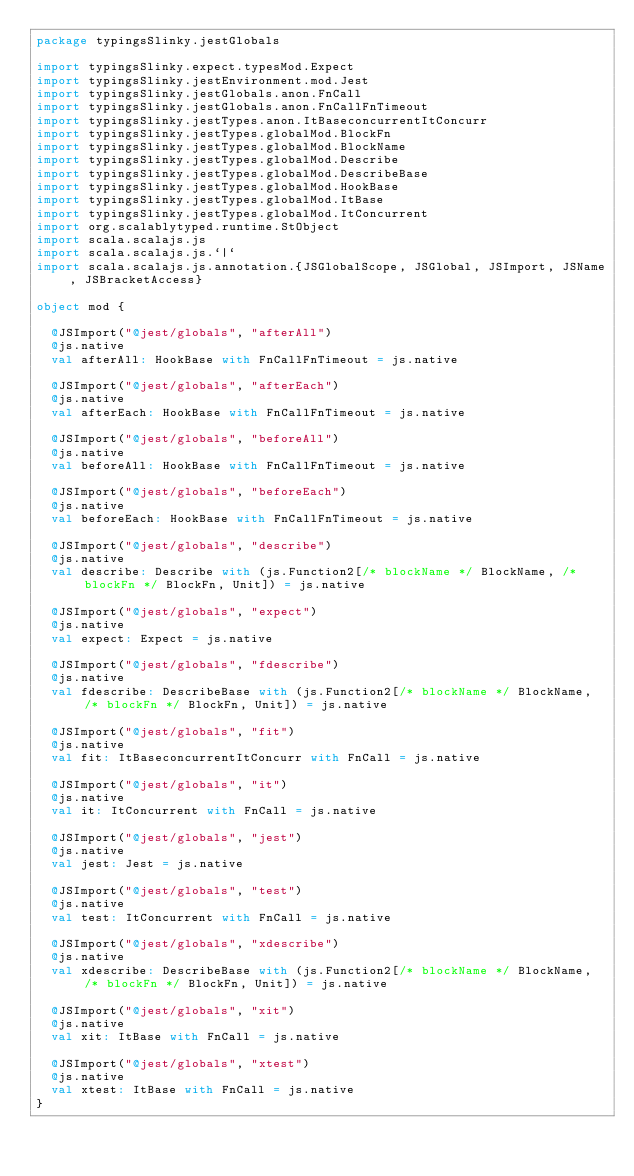Convert code to text. <code><loc_0><loc_0><loc_500><loc_500><_Scala_>package typingsSlinky.jestGlobals

import typingsSlinky.expect.typesMod.Expect
import typingsSlinky.jestEnvironment.mod.Jest
import typingsSlinky.jestGlobals.anon.FnCall
import typingsSlinky.jestGlobals.anon.FnCallFnTimeout
import typingsSlinky.jestTypes.anon.ItBaseconcurrentItConcurr
import typingsSlinky.jestTypes.globalMod.BlockFn
import typingsSlinky.jestTypes.globalMod.BlockName
import typingsSlinky.jestTypes.globalMod.Describe
import typingsSlinky.jestTypes.globalMod.DescribeBase
import typingsSlinky.jestTypes.globalMod.HookBase
import typingsSlinky.jestTypes.globalMod.ItBase
import typingsSlinky.jestTypes.globalMod.ItConcurrent
import org.scalablytyped.runtime.StObject
import scala.scalajs.js
import scala.scalajs.js.`|`
import scala.scalajs.js.annotation.{JSGlobalScope, JSGlobal, JSImport, JSName, JSBracketAccess}

object mod {
  
  @JSImport("@jest/globals", "afterAll")
  @js.native
  val afterAll: HookBase with FnCallFnTimeout = js.native
  
  @JSImport("@jest/globals", "afterEach")
  @js.native
  val afterEach: HookBase with FnCallFnTimeout = js.native
  
  @JSImport("@jest/globals", "beforeAll")
  @js.native
  val beforeAll: HookBase with FnCallFnTimeout = js.native
  
  @JSImport("@jest/globals", "beforeEach")
  @js.native
  val beforeEach: HookBase with FnCallFnTimeout = js.native
  
  @JSImport("@jest/globals", "describe")
  @js.native
  val describe: Describe with (js.Function2[/* blockName */ BlockName, /* blockFn */ BlockFn, Unit]) = js.native
  
  @JSImport("@jest/globals", "expect")
  @js.native
  val expect: Expect = js.native
  
  @JSImport("@jest/globals", "fdescribe")
  @js.native
  val fdescribe: DescribeBase with (js.Function2[/* blockName */ BlockName, /* blockFn */ BlockFn, Unit]) = js.native
  
  @JSImport("@jest/globals", "fit")
  @js.native
  val fit: ItBaseconcurrentItConcurr with FnCall = js.native
  
  @JSImport("@jest/globals", "it")
  @js.native
  val it: ItConcurrent with FnCall = js.native
  
  @JSImport("@jest/globals", "jest")
  @js.native
  val jest: Jest = js.native
  
  @JSImport("@jest/globals", "test")
  @js.native
  val test: ItConcurrent with FnCall = js.native
  
  @JSImport("@jest/globals", "xdescribe")
  @js.native
  val xdescribe: DescribeBase with (js.Function2[/* blockName */ BlockName, /* blockFn */ BlockFn, Unit]) = js.native
  
  @JSImport("@jest/globals", "xit")
  @js.native
  val xit: ItBase with FnCall = js.native
  
  @JSImport("@jest/globals", "xtest")
  @js.native
  val xtest: ItBase with FnCall = js.native
}
</code> 